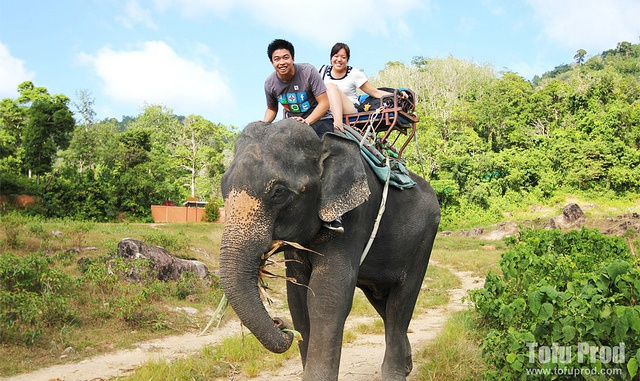Describe the objects in this image and their specific colors. I can see elephant in lightblue, black, gray, and tan tones, people in lightblue, black, gray, darkgray, and brown tones, bench in lightblue, black, gray, brown, and lightpink tones, people in lightblue, white, tan, and brown tones, and backpack in lightblue, black, and gray tones in this image. 